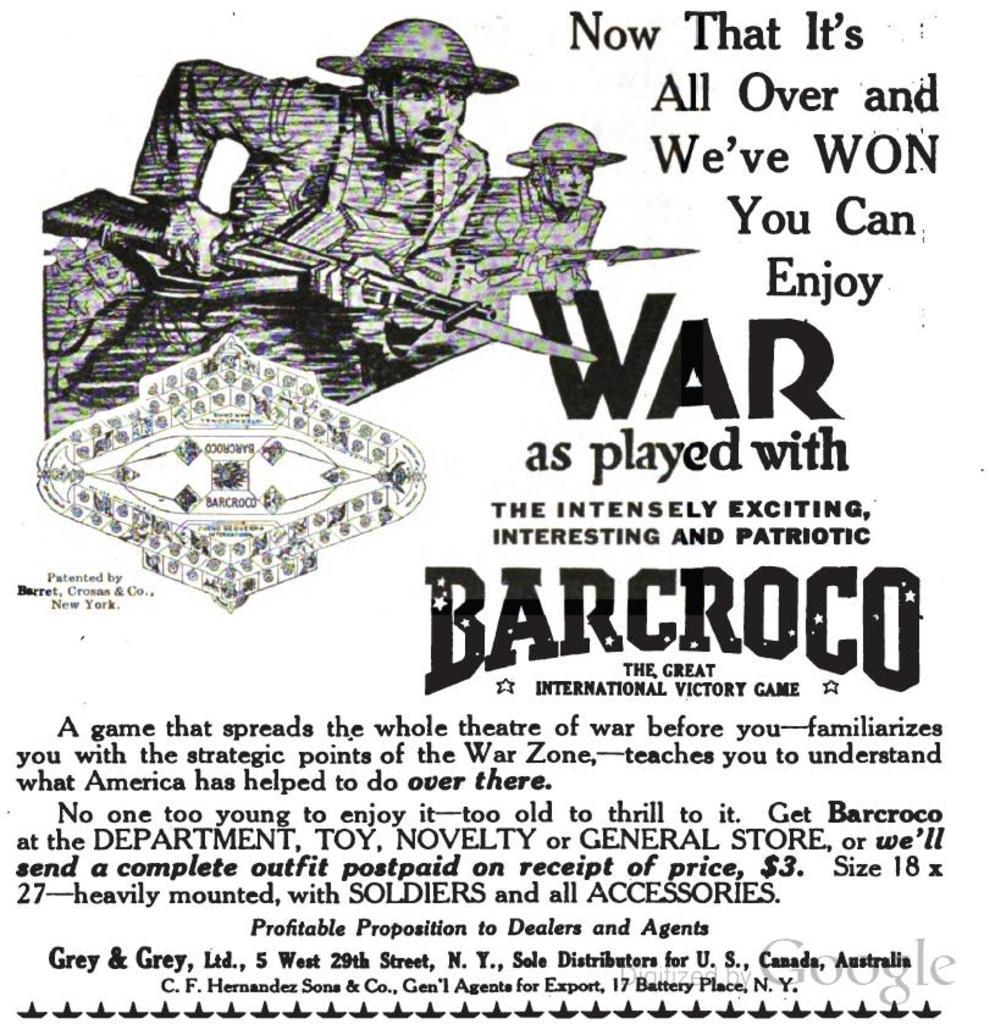Provide a one-sentence caption for the provided image. An advertisement for Barcroco shows army men with guns. 